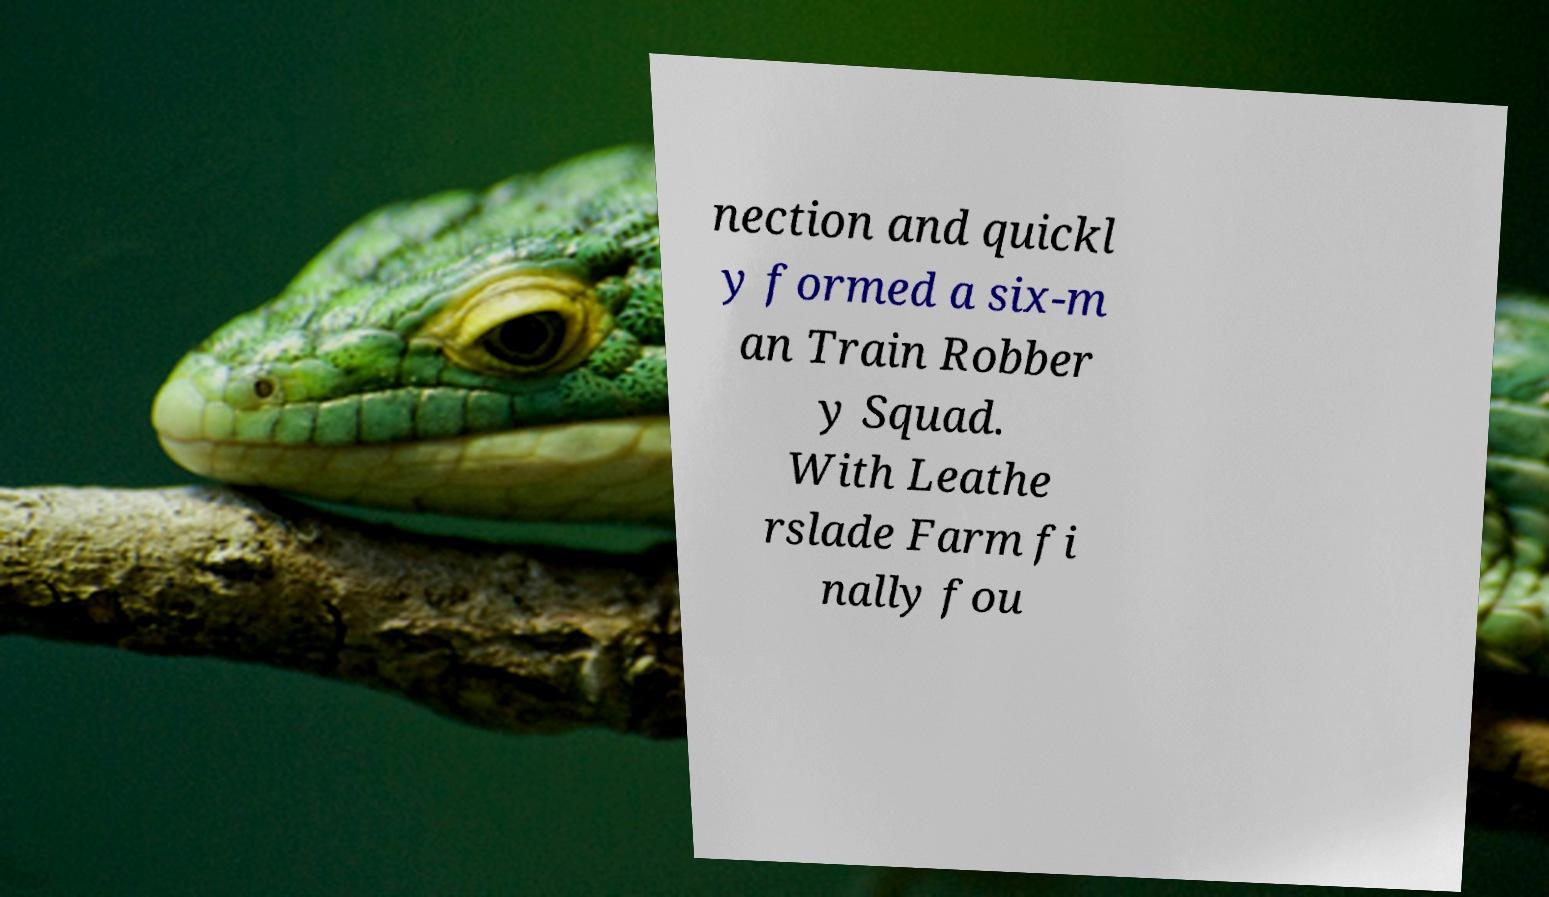Could you extract and type out the text from this image? nection and quickl y formed a six-m an Train Robber y Squad. With Leathe rslade Farm fi nally fou 